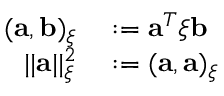<formula> <loc_0><loc_0><loc_500><loc_500>\begin{array} { r l } { ( a , b ) _ { \xi } } & \colon = a ^ { T } \xi b } \\ { | | a | | _ { \xi } ^ { 2 } } & \colon = ( a , a ) _ { \xi } } \end{array}</formula> 